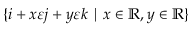Convert formula to latex. <formula><loc_0><loc_0><loc_500><loc_500>\{ i + x \varepsilon j + y \varepsilon k | x \in \mathbb { R } , y \in \mathbb { R } \}</formula> 